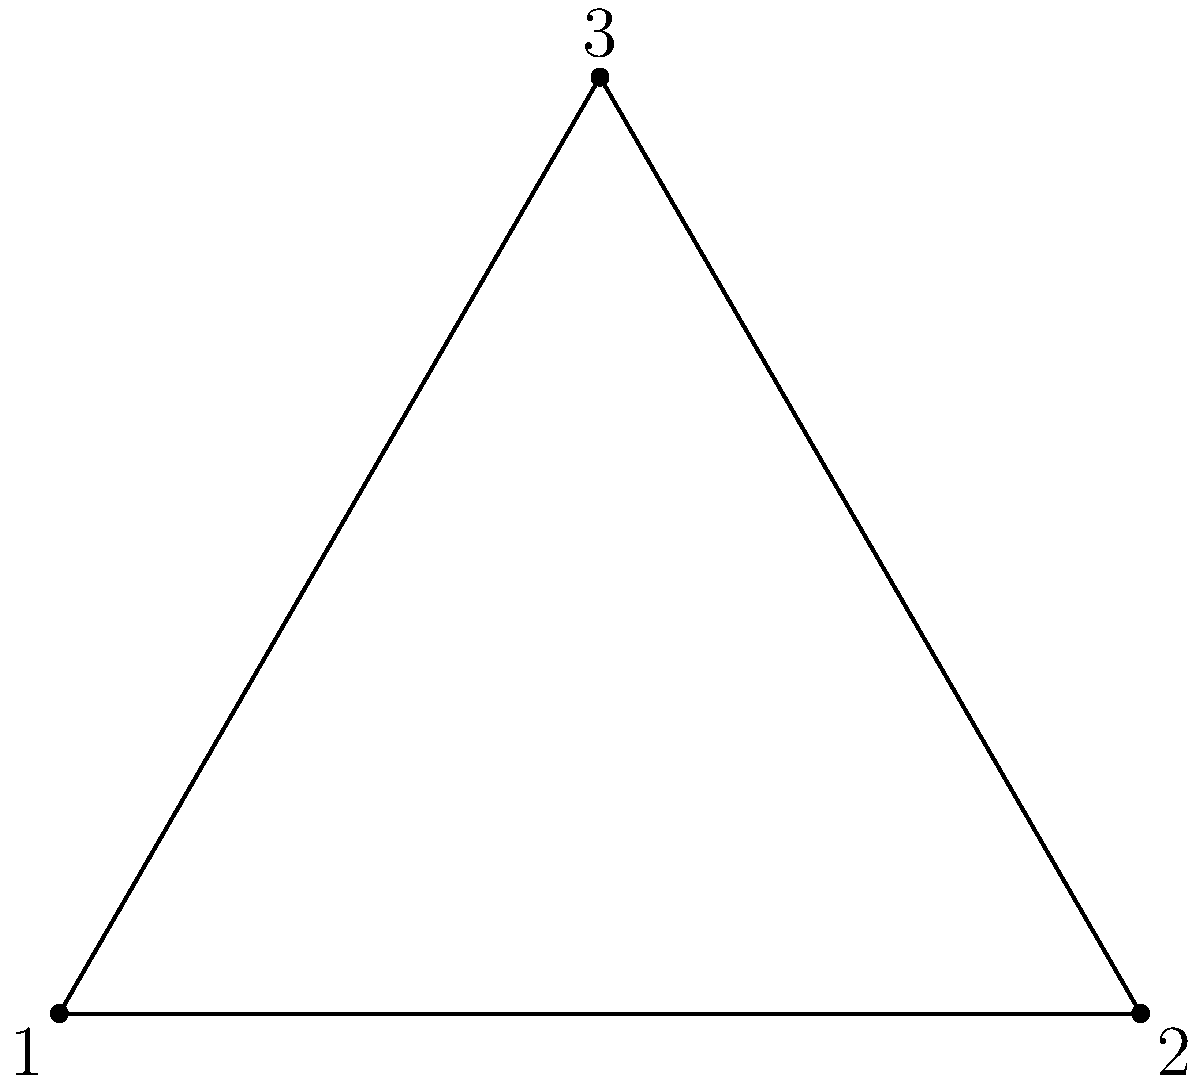In a visual inspection of triangular product components, you notice that defects often appear in patterns with rotational symmetry. The diagram shows three overlapping triangles representing different orientations of a component. If the symmetry group of the defect pattern corresponds to the rotational symmetry group of an equilateral triangle, what is the order of this group? To determine the order of the rotational symmetry group of an equilateral triangle, we need to follow these steps:

1. Identify the rotational symmetries:
   - 0° rotation (identity)
   - 120° clockwise rotation
   - 240° clockwise rotation (equivalent to 120° counterclockwise)

2. Count the number of distinct rotations:
   There are 3 distinct rotations (including the identity rotation).

3. Understand the group structure:
   - These rotations form a group under composition.
   - The group is cyclic, generated by the 120° rotation.
   - It is isomorphic to the cyclic group $C_3$ or $\mathbb{Z}_3$.

4. Determine the order of the group:
   The order of a group is the number of elements in the group.
   In this case, there are 3 elements.

Therefore, the order of the rotational symmetry group of an equilateral triangle is 3.
Answer: 3 